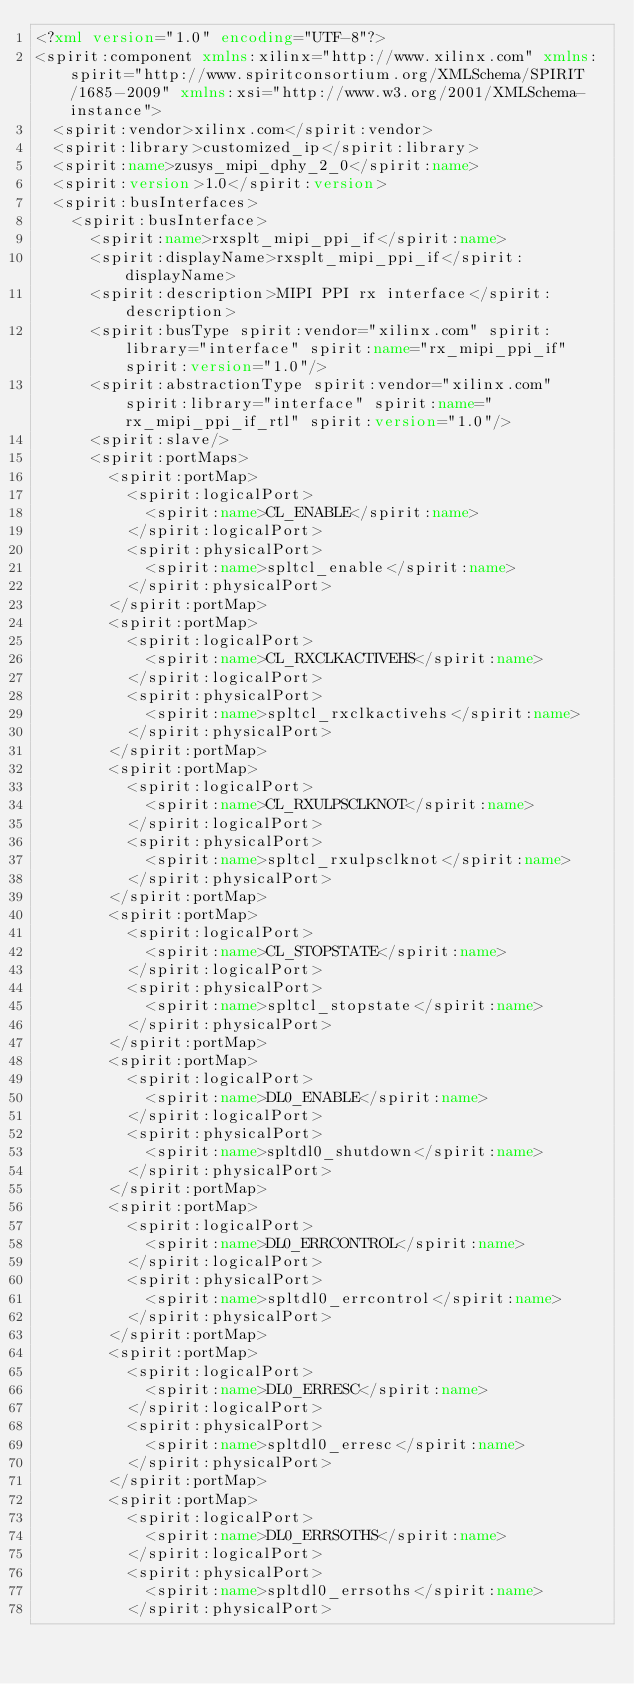<code> <loc_0><loc_0><loc_500><loc_500><_XML_><?xml version="1.0" encoding="UTF-8"?>
<spirit:component xmlns:xilinx="http://www.xilinx.com" xmlns:spirit="http://www.spiritconsortium.org/XMLSchema/SPIRIT/1685-2009" xmlns:xsi="http://www.w3.org/2001/XMLSchema-instance">
  <spirit:vendor>xilinx.com</spirit:vendor>
  <spirit:library>customized_ip</spirit:library>
  <spirit:name>zusys_mipi_dphy_2_0</spirit:name>
  <spirit:version>1.0</spirit:version>
  <spirit:busInterfaces>
    <spirit:busInterface>
      <spirit:name>rxsplt_mipi_ppi_if</spirit:name>
      <spirit:displayName>rxsplt_mipi_ppi_if</spirit:displayName>
      <spirit:description>MIPI PPI rx interface</spirit:description>
      <spirit:busType spirit:vendor="xilinx.com" spirit:library="interface" spirit:name="rx_mipi_ppi_if" spirit:version="1.0"/>
      <spirit:abstractionType spirit:vendor="xilinx.com" spirit:library="interface" spirit:name="rx_mipi_ppi_if_rtl" spirit:version="1.0"/>
      <spirit:slave/>
      <spirit:portMaps>
        <spirit:portMap>
          <spirit:logicalPort>
            <spirit:name>CL_ENABLE</spirit:name>
          </spirit:logicalPort>
          <spirit:physicalPort>
            <spirit:name>spltcl_enable</spirit:name>
          </spirit:physicalPort>
        </spirit:portMap>
        <spirit:portMap>
          <spirit:logicalPort>
            <spirit:name>CL_RXCLKACTIVEHS</spirit:name>
          </spirit:logicalPort>
          <spirit:physicalPort>
            <spirit:name>spltcl_rxclkactivehs</spirit:name>
          </spirit:physicalPort>
        </spirit:portMap>
        <spirit:portMap>
          <spirit:logicalPort>
            <spirit:name>CL_RXULPSCLKNOT</spirit:name>
          </spirit:logicalPort>
          <spirit:physicalPort>
            <spirit:name>spltcl_rxulpsclknot</spirit:name>
          </spirit:physicalPort>
        </spirit:portMap>
        <spirit:portMap>
          <spirit:logicalPort>
            <spirit:name>CL_STOPSTATE</spirit:name>
          </spirit:logicalPort>
          <spirit:physicalPort>
            <spirit:name>spltcl_stopstate</spirit:name>
          </spirit:physicalPort>
        </spirit:portMap>
        <spirit:portMap>
          <spirit:logicalPort>
            <spirit:name>DL0_ENABLE</spirit:name>
          </spirit:logicalPort>
          <spirit:physicalPort>
            <spirit:name>spltdl0_shutdown</spirit:name>
          </spirit:physicalPort>
        </spirit:portMap>
        <spirit:portMap>
          <spirit:logicalPort>
            <spirit:name>DL0_ERRCONTROL</spirit:name>
          </spirit:logicalPort>
          <spirit:physicalPort>
            <spirit:name>spltdl0_errcontrol</spirit:name>
          </spirit:physicalPort>
        </spirit:portMap>
        <spirit:portMap>
          <spirit:logicalPort>
            <spirit:name>DL0_ERRESC</spirit:name>
          </spirit:logicalPort>
          <spirit:physicalPort>
            <spirit:name>spltdl0_erresc</spirit:name>
          </spirit:physicalPort>
        </spirit:portMap>
        <spirit:portMap>
          <spirit:logicalPort>
            <spirit:name>DL0_ERRSOTHS</spirit:name>
          </spirit:logicalPort>
          <spirit:physicalPort>
            <spirit:name>spltdl0_errsoths</spirit:name>
          </spirit:physicalPort></code> 